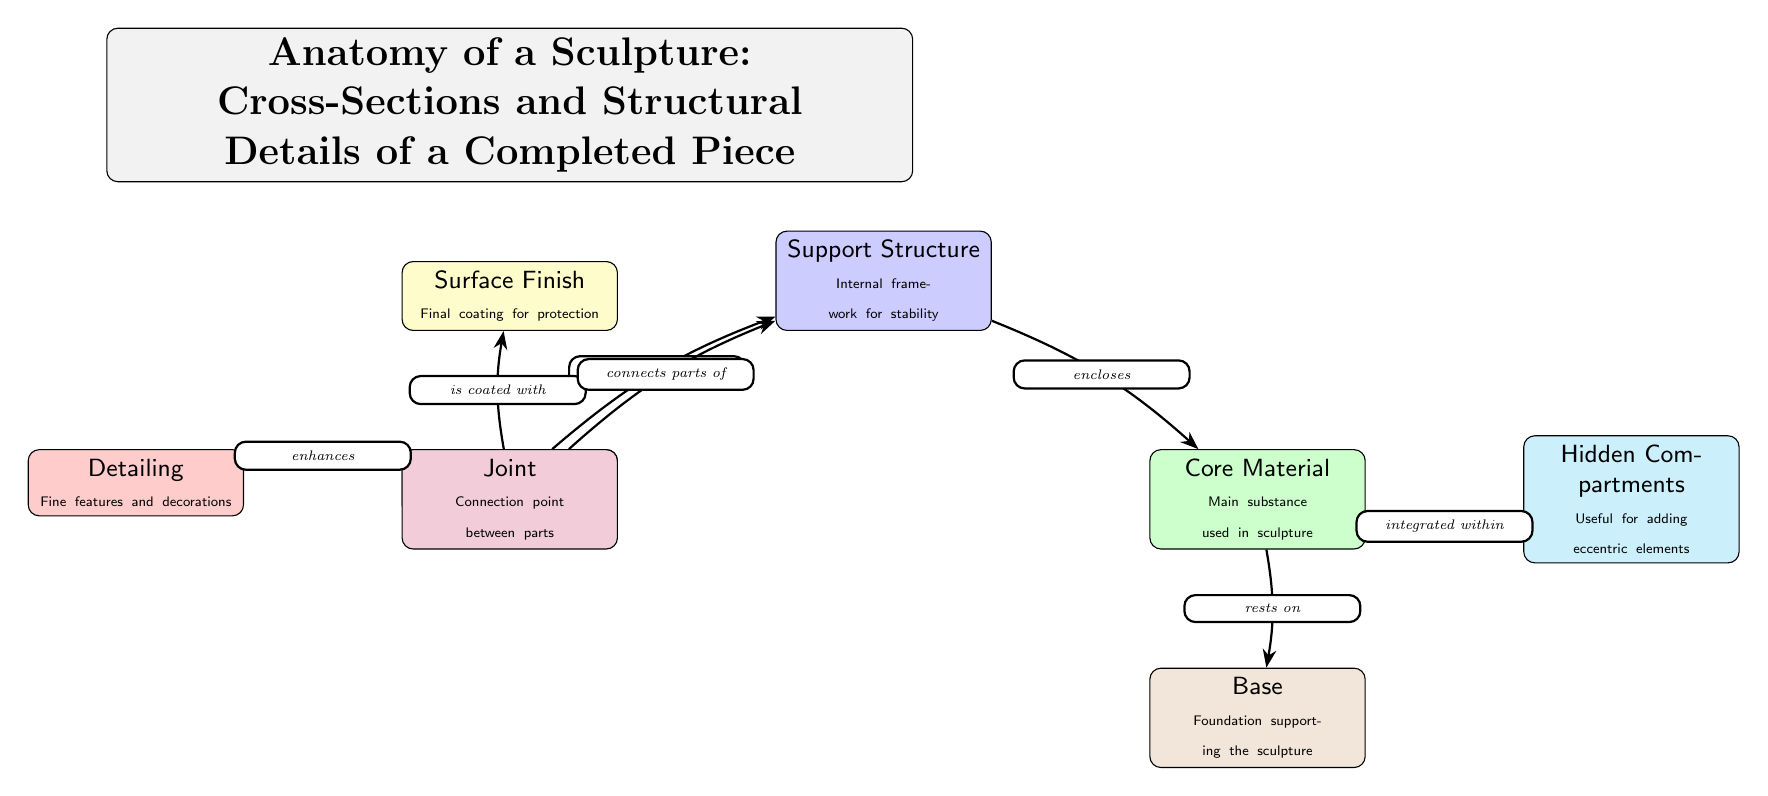What is the outer layer of the sculpture called? The diagram labels the outer layer of the sculpture as "Outer Layer." Therefore, this is the name we are looking for.
Answer: Outer Layer What connects two parts of the support structure? The diagram identifies a "Joint" as the connection point between parts. Therefore, the answer to the question is the term provided in the diagram.
Answer: Joint What is the main substance used in the sculpture? According to the diagram, the node labeled "Core Material" describes the main substance used in the sculpture. Thus, this node gives us the term we need.
Answer: Core Material How many components are integrated within the core material? The diagram specifies "Hidden Compartments" as the component integrated within the core material. The diagram features one such node, indicating there is one component.
Answer: Hidden Compartments What additional feature enhances the outer layer? The diagram shows "Detailing" as the fine features and decorations that enhance the outer layer. Therefore, this is the feature that answers the question asked.
Answer: Detailing What does the support structure enclose? The diagram indicates that the support structure "encloses" the core material. Hence, we refer to the node describing what is enclosed, which is the term "Core Material."
Answer: Core Material What does the outer layer rest on? The relationship in the diagram clearly states that the outer layer "is supported by" the support structure. To answer the question, we look upward toward the node that is the support for the outer layer.
Answer: Support Structure What is the purpose of the surface finish? The diagram specifies that the surface finish provides "Final coating for protection." Therefore, we can state that the purpose of the surface finish is to protect the sculpture.
Answer: Protection What does the core material rest on? The diagram specifies that the core material "rests on" the base. Hence, we can ascertain the answer by looking at the node located just below the core material, which describes the base's function.
Answer: Base 